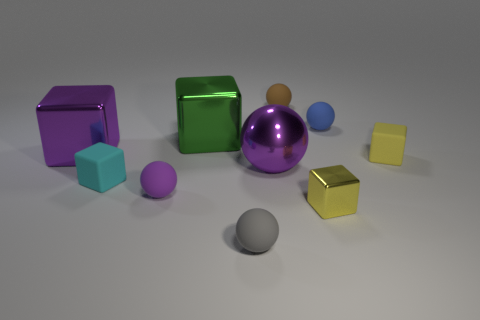Is the material of the brown sphere the same as the small yellow block that is on the right side of the blue object?
Provide a short and direct response. Yes. There is a ball that is made of the same material as the green thing; what size is it?
Your answer should be very brief. Large. Is the number of small yellow metal things behind the tiny blue ball greater than the number of big metal spheres that are behind the large purple shiny cube?
Your answer should be compact. No. Is there another purple rubber object of the same shape as the purple rubber object?
Make the answer very short. No. There is a yellow block behind the yellow shiny thing; does it have the same size as the gray thing?
Offer a very short reply. Yes. Are any blue things visible?
Ensure brevity in your answer.  Yes. What number of things are large purple objects that are on the right side of the large purple cube or big red matte objects?
Your response must be concise. 1. Do the big sphere and the big metal block that is behind the large purple metal cube have the same color?
Your answer should be compact. No. Is there a blue matte block of the same size as the brown sphere?
Give a very brief answer. No. The purple thing that is on the left side of the matte ball that is left of the small gray sphere is made of what material?
Give a very brief answer. Metal. 